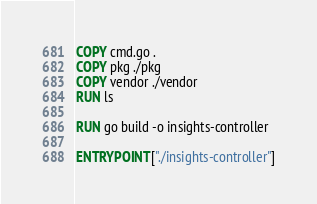<code> <loc_0><loc_0><loc_500><loc_500><_Dockerfile_>
COPY cmd.go .
COPY pkg ./pkg
COPY vendor ./vendor
RUN ls

RUN go build -o insights-controller

ENTRYPOINT ["./insights-controller"]
</code> 